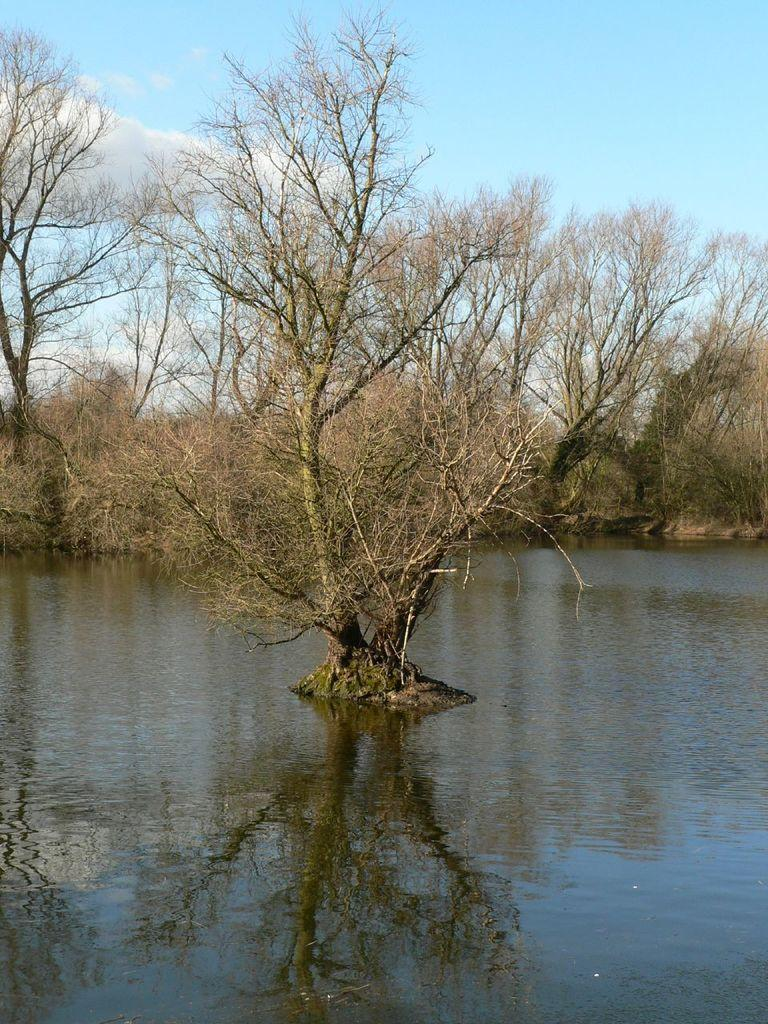What is the main subject in the center of the image? There is a tree in the pond in the center of the image. What can be seen in the background of the image? There are many trees in the background of the image. What is visible beyond the trees in the background? The sky is visible in the background of the image. What can be observed in the sky? Clouds are present in the sky. What type of quartz can be seen in the image? There is no quartz present in the image. What is the condition of the tree in the center of the image? The condition of the tree cannot be determined from the image alone, as it only provides a visual representation of the tree's location and surroundings. 